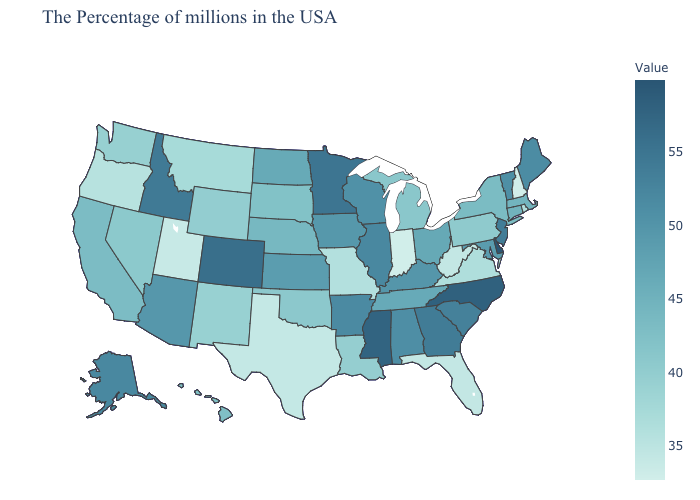Does Utah have the lowest value in the West?
Concise answer only. Yes. Which states have the lowest value in the Northeast?
Concise answer only. New Hampshire. Among the states that border Ohio , which have the lowest value?
Keep it brief. Indiana. Does Texas have the lowest value in the South?
Write a very short answer. Yes. Which states have the highest value in the USA?
Be succinct. Delaware. Does Minnesota have the highest value in the MidWest?
Write a very short answer. Yes. Does Rhode Island have the lowest value in the USA?
Be succinct. No. 